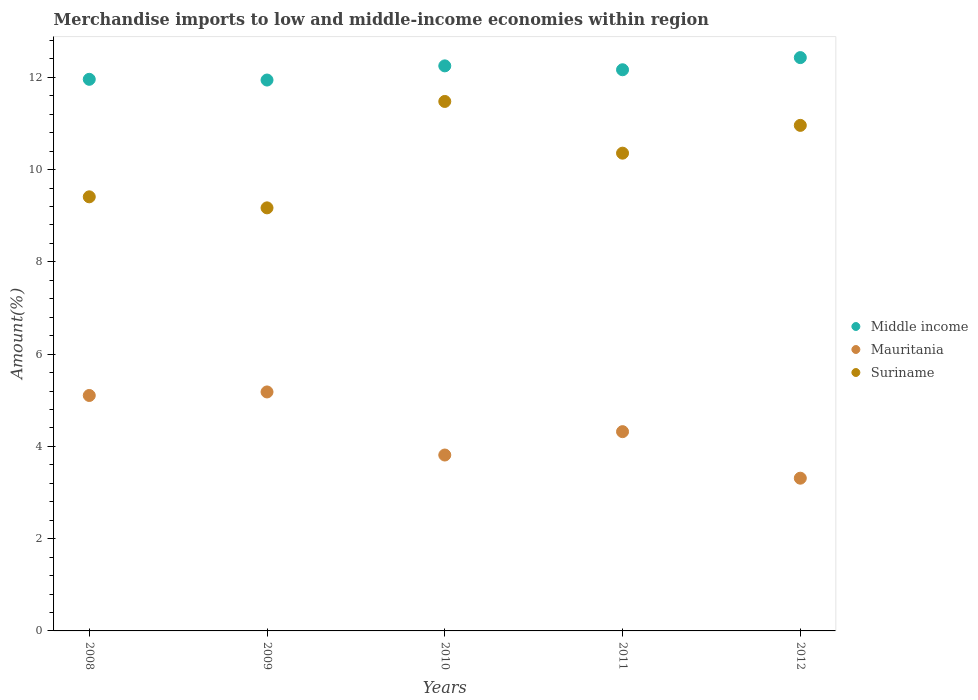What is the percentage of amount earned from merchandise imports in Suriname in 2012?
Provide a short and direct response. 10.96. Across all years, what is the maximum percentage of amount earned from merchandise imports in Middle income?
Keep it short and to the point. 12.43. Across all years, what is the minimum percentage of amount earned from merchandise imports in Suriname?
Give a very brief answer. 9.17. In which year was the percentage of amount earned from merchandise imports in Mauritania minimum?
Provide a short and direct response. 2012. What is the total percentage of amount earned from merchandise imports in Middle income in the graph?
Your answer should be compact. 60.74. What is the difference between the percentage of amount earned from merchandise imports in Mauritania in 2010 and that in 2011?
Provide a short and direct response. -0.51. What is the difference between the percentage of amount earned from merchandise imports in Mauritania in 2011 and the percentage of amount earned from merchandise imports in Suriname in 2008?
Your answer should be very brief. -5.09. What is the average percentage of amount earned from merchandise imports in Suriname per year?
Your answer should be very brief. 10.27. In the year 2011, what is the difference between the percentage of amount earned from merchandise imports in Mauritania and percentage of amount earned from merchandise imports in Suriname?
Give a very brief answer. -6.04. In how many years, is the percentage of amount earned from merchandise imports in Mauritania greater than 4.4 %?
Make the answer very short. 2. What is the ratio of the percentage of amount earned from merchandise imports in Middle income in 2009 to that in 2010?
Ensure brevity in your answer.  0.97. Is the difference between the percentage of amount earned from merchandise imports in Mauritania in 2011 and 2012 greater than the difference between the percentage of amount earned from merchandise imports in Suriname in 2011 and 2012?
Offer a terse response. Yes. What is the difference between the highest and the second highest percentage of amount earned from merchandise imports in Mauritania?
Offer a terse response. 0.08. What is the difference between the highest and the lowest percentage of amount earned from merchandise imports in Mauritania?
Provide a succinct answer. 1.87. In how many years, is the percentage of amount earned from merchandise imports in Mauritania greater than the average percentage of amount earned from merchandise imports in Mauritania taken over all years?
Provide a short and direct response. 2. Is the sum of the percentage of amount earned from merchandise imports in Suriname in 2008 and 2009 greater than the maximum percentage of amount earned from merchandise imports in Middle income across all years?
Provide a succinct answer. Yes. Is the percentage of amount earned from merchandise imports in Mauritania strictly greater than the percentage of amount earned from merchandise imports in Suriname over the years?
Your answer should be compact. No. How many dotlines are there?
Keep it short and to the point. 3. Does the graph contain grids?
Offer a terse response. No. Where does the legend appear in the graph?
Your response must be concise. Center right. How many legend labels are there?
Provide a succinct answer. 3. What is the title of the graph?
Provide a short and direct response. Merchandise imports to low and middle-income economies within region. Does "OECD members" appear as one of the legend labels in the graph?
Offer a terse response. No. What is the label or title of the Y-axis?
Offer a very short reply. Amount(%). What is the Amount(%) of Middle income in 2008?
Provide a short and direct response. 11.96. What is the Amount(%) of Mauritania in 2008?
Your answer should be very brief. 5.1. What is the Amount(%) of Suriname in 2008?
Give a very brief answer. 9.41. What is the Amount(%) in Middle income in 2009?
Offer a very short reply. 11.94. What is the Amount(%) of Mauritania in 2009?
Offer a very short reply. 5.18. What is the Amount(%) of Suriname in 2009?
Ensure brevity in your answer.  9.17. What is the Amount(%) in Middle income in 2010?
Give a very brief answer. 12.25. What is the Amount(%) in Mauritania in 2010?
Your answer should be compact. 3.81. What is the Amount(%) in Suriname in 2010?
Your response must be concise. 11.48. What is the Amount(%) of Middle income in 2011?
Your answer should be very brief. 12.16. What is the Amount(%) of Mauritania in 2011?
Give a very brief answer. 4.32. What is the Amount(%) of Suriname in 2011?
Provide a short and direct response. 10.36. What is the Amount(%) of Middle income in 2012?
Your answer should be compact. 12.43. What is the Amount(%) of Mauritania in 2012?
Make the answer very short. 3.31. What is the Amount(%) in Suriname in 2012?
Your response must be concise. 10.96. Across all years, what is the maximum Amount(%) of Middle income?
Your response must be concise. 12.43. Across all years, what is the maximum Amount(%) in Mauritania?
Ensure brevity in your answer.  5.18. Across all years, what is the maximum Amount(%) of Suriname?
Give a very brief answer. 11.48. Across all years, what is the minimum Amount(%) in Middle income?
Offer a terse response. 11.94. Across all years, what is the minimum Amount(%) of Mauritania?
Provide a succinct answer. 3.31. Across all years, what is the minimum Amount(%) in Suriname?
Provide a short and direct response. 9.17. What is the total Amount(%) in Middle income in the graph?
Keep it short and to the point. 60.74. What is the total Amount(%) of Mauritania in the graph?
Give a very brief answer. 21.73. What is the total Amount(%) of Suriname in the graph?
Keep it short and to the point. 51.37. What is the difference between the Amount(%) in Middle income in 2008 and that in 2009?
Your answer should be compact. 0.02. What is the difference between the Amount(%) in Mauritania in 2008 and that in 2009?
Keep it short and to the point. -0.08. What is the difference between the Amount(%) in Suriname in 2008 and that in 2009?
Keep it short and to the point. 0.24. What is the difference between the Amount(%) of Middle income in 2008 and that in 2010?
Offer a terse response. -0.29. What is the difference between the Amount(%) of Mauritania in 2008 and that in 2010?
Keep it short and to the point. 1.29. What is the difference between the Amount(%) of Suriname in 2008 and that in 2010?
Your answer should be compact. -2.07. What is the difference between the Amount(%) of Middle income in 2008 and that in 2011?
Keep it short and to the point. -0.21. What is the difference between the Amount(%) of Mauritania in 2008 and that in 2011?
Your answer should be very brief. 0.78. What is the difference between the Amount(%) of Suriname in 2008 and that in 2011?
Provide a succinct answer. -0.95. What is the difference between the Amount(%) in Middle income in 2008 and that in 2012?
Your answer should be very brief. -0.47. What is the difference between the Amount(%) in Mauritania in 2008 and that in 2012?
Your answer should be compact. 1.79. What is the difference between the Amount(%) in Suriname in 2008 and that in 2012?
Provide a short and direct response. -1.55. What is the difference between the Amount(%) in Middle income in 2009 and that in 2010?
Your response must be concise. -0.31. What is the difference between the Amount(%) in Mauritania in 2009 and that in 2010?
Ensure brevity in your answer.  1.37. What is the difference between the Amount(%) of Suriname in 2009 and that in 2010?
Keep it short and to the point. -2.31. What is the difference between the Amount(%) in Middle income in 2009 and that in 2011?
Your response must be concise. -0.22. What is the difference between the Amount(%) in Mauritania in 2009 and that in 2011?
Provide a short and direct response. 0.86. What is the difference between the Amount(%) in Suriname in 2009 and that in 2011?
Your response must be concise. -1.19. What is the difference between the Amount(%) of Middle income in 2009 and that in 2012?
Your response must be concise. -0.49. What is the difference between the Amount(%) in Mauritania in 2009 and that in 2012?
Offer a terse response. 1.87. What is the difference between the Amount(%) of Suriname in 2009 and that in 2012?
Make the answer very short. -1.79. What is the difference between the Amount(%) of Middle income in 2010 and that in 2011?
Give a very brief answer. 0.08. What is the difference between the Amount(%) of Mauritania in 2010 and that in 2011?
Provide a short and direct response. -0.51. What is the difference between the Amount(%) of Suriname in 2010 and that in 2011?
Your response must be concise. 1.12. What is the difference between the Amount(%) in Middle income in 2010 and that in 2012?
Make the answer very short. -0.18. What is the difference between the Amount(%) of Mauritania in 2010 and that in 2012?
Your answer should be very brief. 0.5. What is the difference between the Amount(%) of Suriname in 2010 and that in 2012?
Your answer should be very brief. 0.52. What is the difference between the Amount(%) in Middle income in 2011 and that in 2012?
Provide a short and direct response. -0.26. What is the difference between the Amount(%) of Mauritania in 2011 and that in 2012?
Your answer should be compact. 1.01. What is the difference between the Amount(%) of Suriname in 2011 and that in 2012?
Keep it short and to the point. -0.6. What is the difference between the Amount(%) of Middle income in 2008 and the Amount(%) of Mauritania in 2009?
Keep it short and to the point. 6.78. What is the difference between the Amount(%) of Middle income in 2008 and the Amount(%) of Suriname in 2009?
Provide a succinct answer. 2.79. What is the difference between the Amount(%) in Mauritania in 2008 and the Amount(%) in Suriname in 2009?
Offer a terse response. -4.07. What is the difference between the Amount(%) in Middle income in 2008 and the Amount(%) in Mauritania in 2010?
Provide a succinct answer. 8.14. What is the difference between the Amount(%) in Middle income in 2008 and the Amount(%) in Suriname in 2010?
Give a very brief answer. 0.48. What is the difference between the Amount(%) of Mauritania in 2008 and the Amount(%) of Suriname in 2010?
Your answer should be very brief. -6.37. What is the difference between the Amount(%) of Middle income in 2008 and the Amount(%) of Mauritania in 2011?
Provide a short and direct response. 7.64. What is the difference between the Amount(%) of Middle income in 2008 and the Amount(%) of Suriname in 2011?
Your response must be concise. 1.6. What is the difference between the Amount(%) in Mauritania in 2008 and the Amount(%) in Suriname in 2011?
Keep it short and to the point. -5.25. What is the difference between the Amount(%) in Middle income in 2008 and the Amount(%) in Mauritania in 2012?
Provide a short and direct response. 8.65. What is the difference between the Amount(%) of Mauritania in 2008 and the Amount(%) of Suriname in 2012?
Keep it short and to the point. -5.85. What is the difference between the Amount(%) of Middle income in 2009 and the Amount(%) of Mauritania in 2010?
Your answer should be very brief. 8.13. What is the difference between the Amount(%) in Middle income in 2009 and the Amount(%) in Suriname in 2010?
Provide a succinct answer. 0.46. What is the difference between the Amount(%) of Mauritania in 2009 and the Amount(%) of Suriname in 2010?
Your answer should be very brief. -6.3. What is the difference between the Amount(%) of Middle income in 2009 and the Amount(%) of Mauritania in 2011?
Keep it short and to the point. 7.62. What is the difference between the Amount(%) of Middle income in 2009 and the Amount(%) of Suriname in 2011?
Offer a terse response. 1.59. What is the difference between the Amount(%) of Mauritania in 2009 and the Amount(%) of Suriname in 2011?
Provide a short and direct response. -5.18. What is the difference between the Amount(%) of Middle income in 2009 and the Amount(%) of Mauritania in 2012?
Provide a succinct answer. 8.63. What is the difference between the Amount(%) of Middle income in 2009 and the Amount(%) of Suriname in 2012?
Keep it short and to the point. 0.98. What is the difference between the Amount(%) in Mauritania in 2009 and the Amount(%) in Suriname in 2012?
Offer a very short reply. -5.78. What is the difference between the Amount(%) in Middle income in 2010 and the Amount(%) in Mauritania in 2011?
Keep it short and to the point. 7.93. What is the difference between the Amount(%) in Middle income in 2010 and the Amount(%) in Suriname in 2011?
Keep it short and to the point. 1.89. What is the difference between the Amount(%) in Mauritania in 2010 and the Amount(%) in Suriname in 2011?
Give a very brief answer. -6.54. What is the difference between the Amount(%) of Middle income in 2010 and the Amount(%) of Mauritania in 2012?
Offer a very short reply. 8.94. What is the difference between the Amount(%) in Middle income in 2010 and the Amount(%) in Suriname in 2012?
Keep it short and to the point. 1.29. What is the difference between the Amount(%) of Mauritania in 2010 and the Amount(%) of Suriname in 2012?
Offer a terse response. -7.15. What is the difference between the Amount(%) of Middle income in 2011 and the Amount(%) of Mauritania in 2012?
Make the answer very short. 8.85. What is the difference between the Amount(%) of Middle income in 2011 and the Amount(%) of Suriname in 2012?
Offer a very short reply. 1.21. What is the difference between the Amount(%) of Mauritania in 2011 and the Amount(%) of Suriname in 2012?
Your answer should be very brief. -6.64. What is the average Amount(%) in Middle income per year?
Ensure brevity in your answer.  12.15. What is the average Amount(%) in Mauritania per year?
Provide a succinct answer. 4.35. What is the average Amount(%) of Suriname per year?
Ensure brevity in your answer.  10.27. In the year 2008, what is the difference between the Amount(%) in Middle income and Amount(%) in Mauritania?
Make the answer very short. 6.85. In the year 2008, what is the difference between the Amount(%) in Middle income and Amount(%) in Suriname?
Provide a succinct answer. 2.55. In the year 2008, what is the difference between the Amount(%) of Mauritania and Amount(%) of Suriname?
Keep it short and to the point. -4.31. In the year 2009, what is the difference between the Amount(%) in Middle income and Amount(%) in Mauritania?
Your answer should be compact. 6.76. In the year 2009, what is the difference between the Amount(%) in Middle income and Amount(%) in Suriname?
Your answer should be very brief. 2.77. In the year 2009, what is the difference between the Amount(%) in Mauritania and Amount(%) in Suriname?
Provide a succinct answer. -3.99. In the year 2010, what is the difference between the Amount(%) of Middle income and Amount(%) of Mauritania?
Provide a succinct answer. 8.44. In the year 2010, what is the difference between the Amount(%) in Middle income and Amount(%) in Suriname?
Ensure brevity in your answer.  0.77. In the year 2010, what is the difference between the Amount(%) of Mauritania and Amount(%) of Suriname?
Give a very brief answer. -7.66. In the year 2011, what is the difference between the Amount(%) of Middle income and Amount(%) of Mauritania?
Provide a succinct answer. 7.84. In the year 2011, what is the difference between the Amount(%) of Middle income and Amount(%) of Suriname?
Make the answer very short. 1.81. In the year 2011, what is the difference between the Amount(%) in Mauritania and Amount(%) in Suriname?
Your answer should be compact. -6.04. In the year 2012, what is the difference between the Amount(%) in Middle income and Amount(%) in Mauritania?
Offer a very short reply. 9.12. In the year 2012, what is the difference between the Amount(%) in Middle income and Amount(%) in Suriname?
Make the answer very short. 1.47. In the year 2012, what is the difference between the Amount(%) in Mauritania and Amount(%) in Suriname?
Make the answer very short. -7.65. What is the ratio of the Amount(%) in Middle income in 2008 to that in 2009?
Your answer should be compact. 1. What is the ratio of the Amount(%) of Mauritania in 2008 to that in 2009?
Offer a terse response. 0.99. What is the ratio of the Amount(%) of Suriname in 2008 to that in 2009?
Offer a terse response. 1.03. What is the ratio of the Amount(%) in Middle income in 2008 to that in 2010?
Keep it short and to the point. 0.98. What is the ratio of the Amount(%) of Mauritania in 2008 to that in 2010?
Your answer should be very brief. 1.34. What is the ratio of the Amount(%) in Suriname in 2008 to that in 2010?
Give a very brief answer. 0.82. What is the ratio of the Amount(%) of Middle income in 2008 to that in 2011?
Offer a terse response. 0.98. What is the ratio of the Amount(%) in Mauritania in 2008 to that in 2011?
Give a very brief answer. 1.18. What is the ratio of the Amount(%) of Suriname in 2008 to that in 2011?
Make the answer very short. 0.91. What is the ratio of the Amount(%) in Middle income in 2008 to that in 2012?
Offer a very short reply. 0.96. What is the ratio of the Amount(%) in Mauritania in 2008 to that in 2012?
Give a very brief answer. 1.54. What is the ratio of the Amount(%) of Suriname in 2008 to that in 2012?
Offer a very short reply. 0.86. What is the ratio of the Amount(%) of Middle income in 2009 to that in 2010?
Your answer should be compact. 0.97. What is the ratio of the Amount(%) of Mauritania in 2009 to that in 2010?
Offer a terse response. 1.36. What is the ratio of the Amount(%) in Suriname in 2009 to that in 2010?
Your response must be concise. 0.8. What is the ratio of the Amount(%) of Middle income in 2009 to that in 2011?
Your response must be concise. 0.98. What is the ratio of the Amount(%) of Mauritania in 2009 to that in 2011?
Keep it short and to the point. 1.2. What is the ratio of the Amount(%) in Suriname in 2009 to that in 2011?
Provide a succinct answer. 0.89. What is the ratio of the Amount(%) of Middle income in 2009 to that in 2012?
Keep it short and to the point. 0.96. What is the ratio of the Amount(%) of Mauritania in 2009 to that in 2012?
Your response must be concise. 1.56. What is the ratio of the Amount(%) in Suriname in 2009 to that in 2012?
Provide a succinct answer. 0.84. What is the ratio of the Amount(%) of Middle income in 2010 to that in 2011?
Offer a very short reply. 1.01. What is the ratio of the Amount(%) of Mauritania in 2010 to that in 2011?
Offer a terse response. 0.88. What is the ratio of the Amount(%) in Suriname in 2010 to that in 2011?
Offer a terse response. 1.11. What is the ratio of the Amount(%) in Middle income in 2010 to that in 2012?
Offer a terse response. 0.99. What is the ratio of the Amount(%) of Mauritania in 2010 to that in 2012?
Keep it short and to the point. 1.15. What is the ratio of the Amount(%) of Suriname in 2010 to that in 2012?
Your answer should be very brief. 1.05. What is the ratio of the Amount(%) in Middle income in 2011 to that in 2012?
Ensure brevity in your answer.  0.98. What is the ratio of the Amount(%) in Mauritania in 2011 to that in 2012?
Give a very brief answer. 1.3. What is the ratio of the Amount(%) of Suriname in 2011 to that in 2012?
Provide a short and direct response. 0.94. What is the difference between the highest and the second highest Amount(%) of Middle income?
Your answer should be very brief. 0.18. What is the difference between the highest and the second highest Amount(%) in Mauritania?
Give a very brief answer. 0.08. What is the difference between the highest and the second highest Amount(%) in Suriname?
Offer a terse response. 0.52. What is the difference between the highest and the lowest Amount(%) in Middle income?
Make the answer very short. 0.49. What is the difference between the highest and the lowest Amount(%) in Mauritania?
Offer a very short reply. 1.87. What is the difference between the highest and the lowest Amount(%) of Suriname?
Keep it short and to the point. 2.31. 